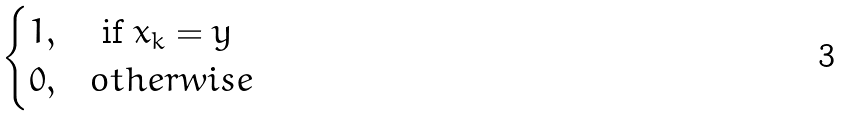Convert formula to latex. <formula><loc_0><loc_0><loc_500><loc_500>\begin{cases} 1 , & \text { if } x _ { k } = y \\ 0 , & o t h e r w i s e \end{cases}</formula> 